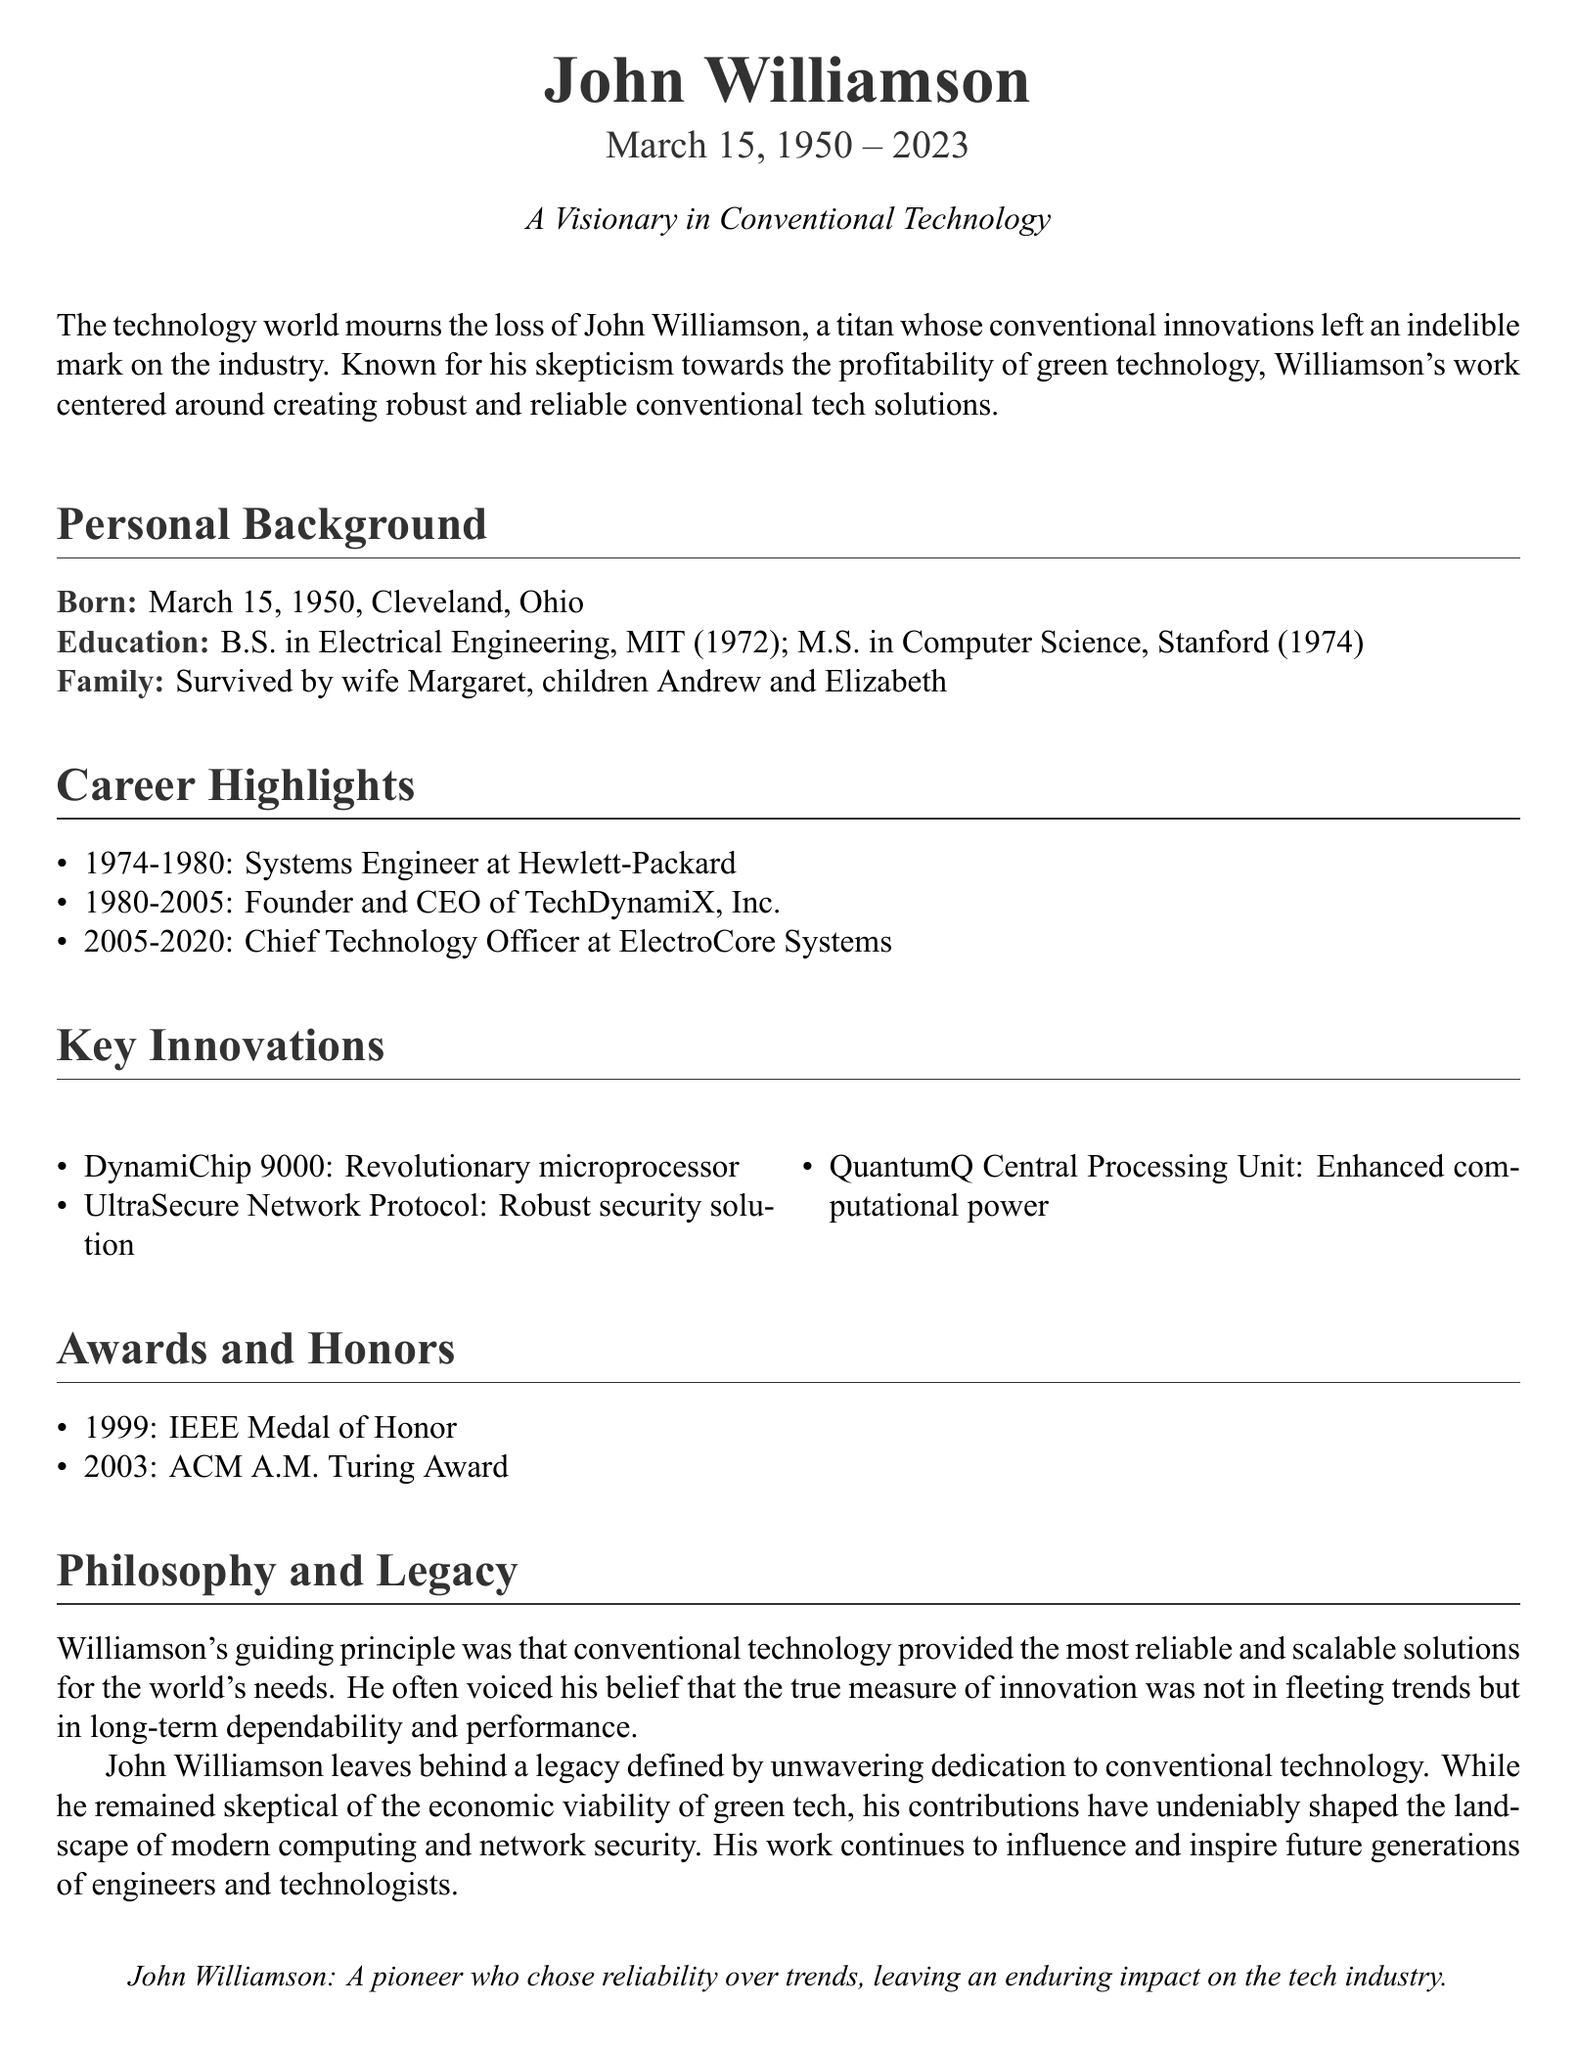What date was John Williamson born? The document states that John Williamson was born on March 15, 1950.
Answer: March 15, 1950 What was John Williamson's highest educational qualification? According to the document, Williamson earned a M.S. in Computer Science from Stanford.
Answer: M.S. in Computer Science How many children did John Williamson have? The document mentions that he is survived by two children: Andrew and Elizabeth.
Answer: Two What company did John Williamson found? The document indicates that he founded TechDynamiX, Inc. in 1980.
Answer: TechDynamiX, Inc What was one of John Williamson's key innovations? The document lists several innovations, one of which is the DynamiChip 9000.
Answer: DynamiChip 9000 Which award did John Williamson receive in 1999? The document specifies that Williamson received the IEEE Medal of Honor in 1999.
Answer: IEEE Medal of Honor What was John Williamson's stance on green technology? The document notes that he was skeptical of the profitability of green technology.
Answer: Skeptical What principle guided John Williamson's work in technology? The document mentions that his guiding principle was reliability and scalability of conventional technology.
Answer: Reliability and scalability What was John Williamson's role at ElectroCore Systems? The document states he served as Chief Technology Officer at ElectroCore Systems from 2005 to 2020.
Answer: Chief Technology Officer 